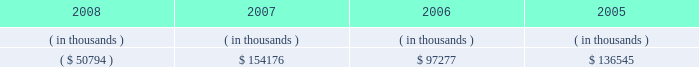Entergy texas , inc .
Management's financial discussion and analysis dividends or other distributions on its common stock .
Currently , all of entergy texas' retained earnings are available for distribution .
Sources of capital entergy texas' sources to meet its capital requirements include : internally generated funds ; cash on hand ; debt or preferred stock issuances ; and bank financing under new or existing facilities .
Entergy texas may refinance or redeem debt prior to maturity , to the extent market conditions and interest and dividend rates are favorable .
All debt and common and preferred stock issuances by entergy texas require prior regulatory approval .
Preferred stock and debt issuances are also subject to issuance tests set forth in its corporate charter , bond indentures , and other agreements .
Entergy texas has sufficient capacity under these tests to meet its foreseeable capital needs .
Entergy gulf states , inc .
Filed with the ferc an application , on behalf of entergy texas , for authority to issue up to $ 200 million of short-term debt , up to $ 300 million of tax-exempt bonds , and up to $ 1.3 billion of other long- term securities , including common and preferred or preference stock and long-term debt .
On november 8 , 2007 , the ferc issued orders granting the requested authority for a two-year period ending november 8 , 2009 .
Entergy texas' receivables from or ( payables to ) the money pool were as follows as of december 31 for each of the following years: .
See note 4 to the financial statements for a description of the money pool .
Entergy texas has a credit facility in the amount of $ 100 million scheduled to expire in august 2012 .
As of december 31 , 2008 , $ 100 million was outstanding on the credit facility .
In february 2009 , entergy texas repaid its credit facility with the proceeds from the bond issuance discussed below .
On june 2 , 2008 and december 8 , 2008 , under the terms of the debt assumption agreement between entergy texas and entergy gulf states louisiana that is discussed in note 5 to the financial statements , entergy texas paid at maturity $ 148.8 million and $ 160.3 million , respectively , of entergy gulf states louisiana first mortgage bonds , which results in a corresponding decrease in entergy texas' debt assumption liability .
In december 2008 , entergy texas borrowed $ 160 million from its parent company , entergy corporation , under a $ 300 million revolving credit facility pursuant to an inter-company credit agreement between entergy corporation and entergy texas .
This borrowing would have matured on december 3 , 2013 .
Entergy texas used these borrowings , together with other available corporate funds , to pay at maturity the portion of the $ 350 million floating rate series of first mortgage bonds due december 2008 that had been assumed by entergy texas , and that bond series is no longer outstanding .
In january 2009 , entergy texas repaid its $ 160 million note payable to entergy corporation with the proceeds from the bond issuance discussed below .
In january 2009 , entergy texas issued $ 500 million of 7.125% ( 7.125 % ) series mortgage bonds due february 2019 .
Entergy texas used a portion of the proceeds to repay its $ 160 million note payable to entergy corporation , to repay the $ 100 million outstanding on its credit facility , and to repay short-term borrowings under the entergy system money pool .
Entergy texas intends to use the remaining proceeds to repay on or prior to maturity approximately $ 70 million of obligations that had been assumed by entergy texas under the debt assumption agreement with entergy gulf states louisiana and for other general corporate purposes. .
What is the annual expense for entergy texas incurred from the series mortgage bonds due february 2019 , in millions? 
Computations: (500 * 7.125%)
Answer: 35.625. 